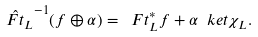Convert formula to latex. <formula><loc_0><loc_0><loc_500><loc_500>\hat { \ F t _ { L } } ^ { - 1 } ( f \oplus \alpha ) = \ F t _ { L } ^ { * } f + \alpha \ k e t { \chi _ { L } } .</formula> 